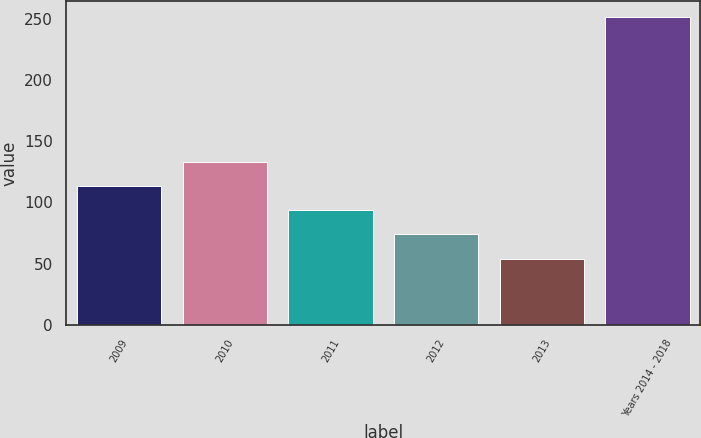Convert chart. <chart><loc_0><loc_0><loc_500><loc_500><bar_chart><fcel>2009<fcel>2010<fcel>2011<fcel>2012<fcel>2013<fcel>Years 2014 - 2018<nl><fcel>113.4<fcel>133.2<fcel>93.6<fcel>73.8<fcel>54<fcel>252<nl></chart> 